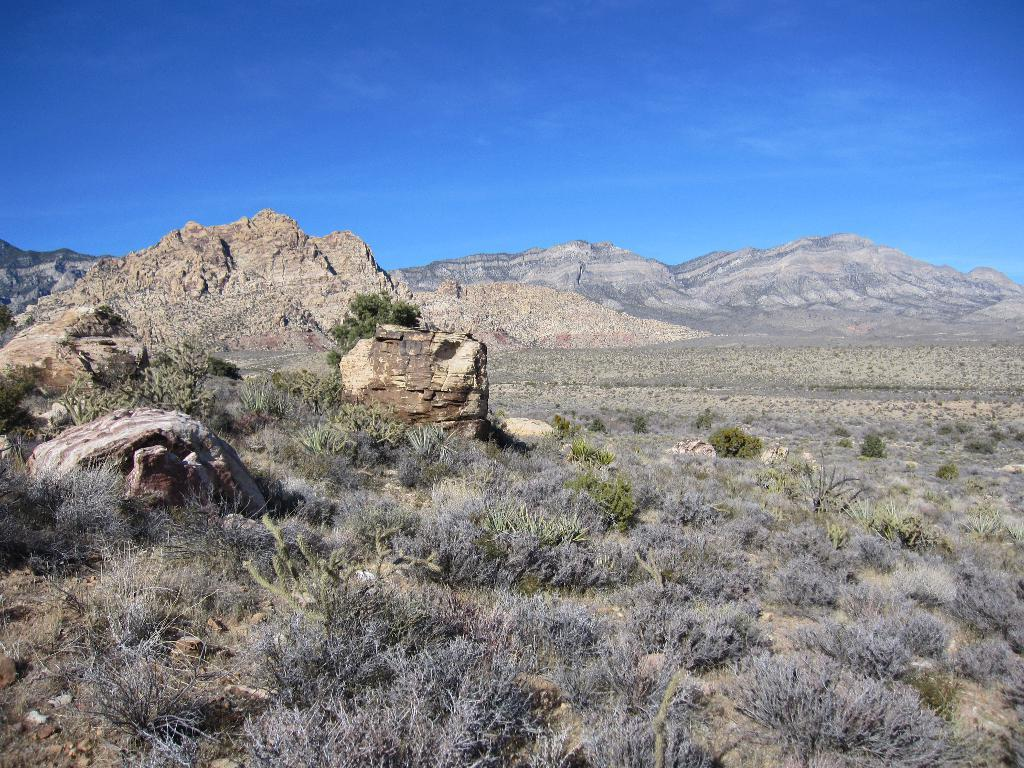What type of landform is visible in the image? There is a mountain in the image. What type of vegetation can be seen in the image? There is grass in the image. What color is the sky in the image? The sky is blue in the image. Can you see the son playing with the beast in the image? There is no son or beast present in the image; it features a mountain, grass, and a blue sky. 